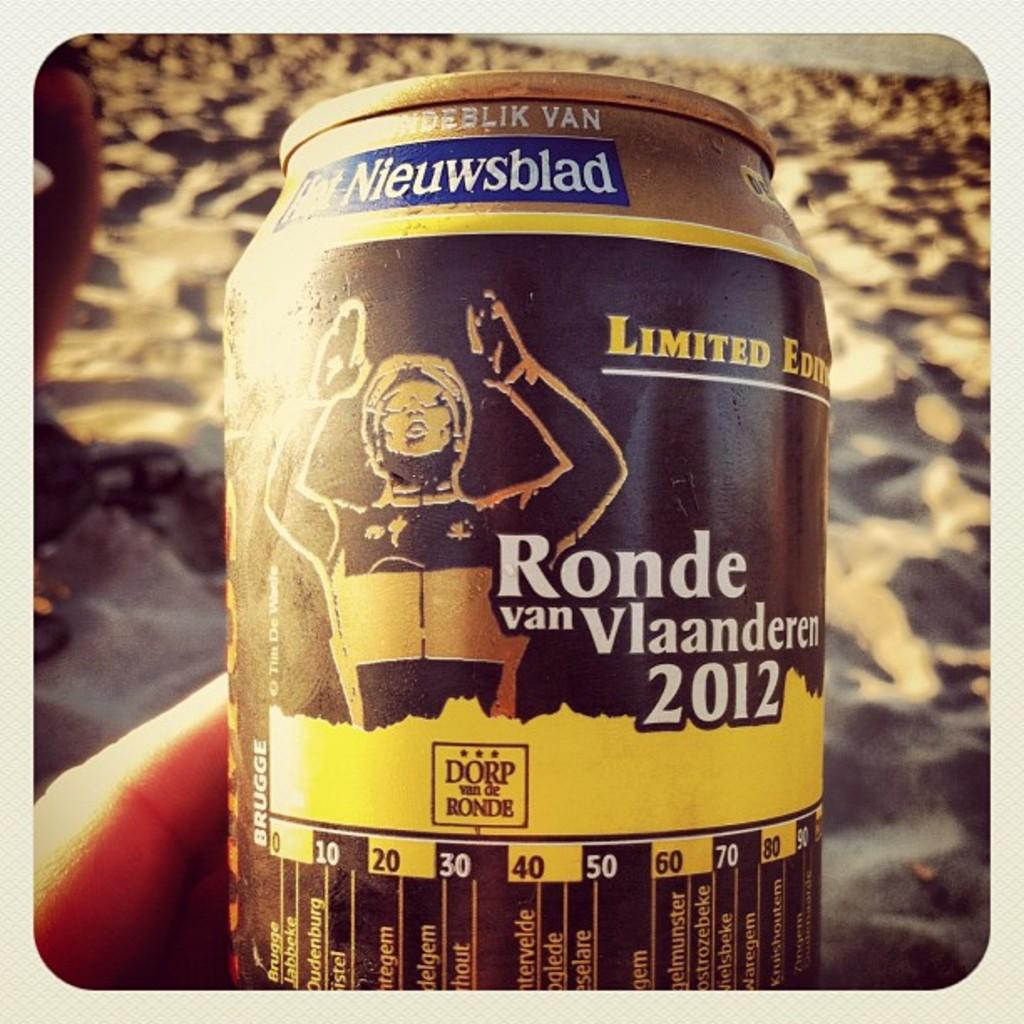<image>
Create a compact narrative representing the image presented. A limited edition beer called Ronde van Vlaanderer 2012. 